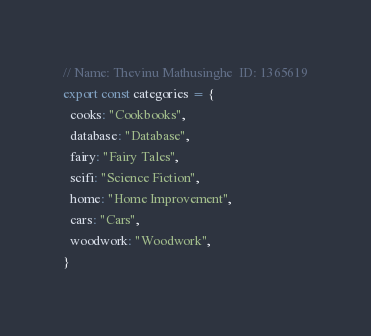Convert code to text. <code><loc_0><loc_0><loc_500><loc_500><_TypeScript_>// Name: Thevinu Mathusinghe  ID: 1365619
export const categories = {
  cooks: "Cookbooks",
  database: "Database",
  fairy: "Fairy Tales",
  scifi: "Science Fiction",
  home: "Home Improvement",
  cars: "Cars",
  woodwork: "Woodwork",
}</code> 